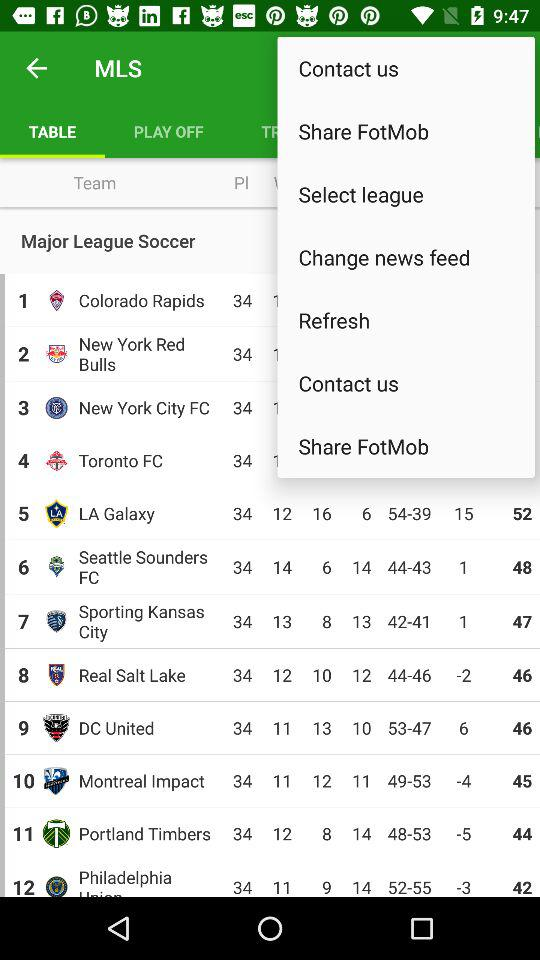How many teams are in the table?
Answer the question using a single word or phrase. 12 